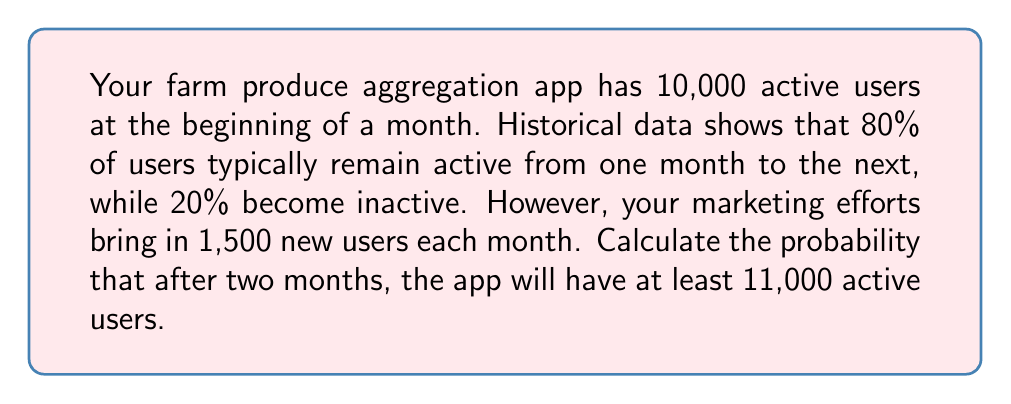Give your solution to this math problem. Let's approach this step-by-step:

1) First, let's calculate the number of active users after one month:
   - Retained users: $10,000 \times 0.8 = 8,000$
   - New users: $1,500$
   - Total after one month: $8,000 + 1,500 = 9,500$

2) Now, let's calculate the possible outcomes after two months:
   - Retained users from first month: $9,500 \times 0.8 = 7,600$
   - New users in second month: $1,500$
   - Total after two months: $7,600 + 1,500 = 9,100$

3) The question asks for the probability of having at least 11,000 users after two months. We can model this as a binomial distribution, where each user has a probability of 0.8 of remaining active.

4) Let $X$ be the number of active users after two months. We need $P(X \geq 11,000)$.

5) We can calculate this as $1 - P(X < 11,000)$

6) Using the normal approximation to the binomial distribution (since n is large):
   $\mu = np = 9,100 \times 0.8 = 7,280$
   $\sigma = \sqrt{np(1-p)} = \sqrt{9,100 \times 0.8 \times 0.2} = 38.17$

7) Standardizing:
   $z = \frac{11,000 - 7,280}{38.17} = 97.46$

8) Using a standard normal table or calculator, we find:
   $P(Z < 97.46) \approx 1$

9) Therefore, $P(X \geq 11,000) = 1 - P(X < 11,000) \approx 1 - 1 = 0$

The probability is essentially zero, meaning it's extremely unlikely to have 11,000 or more active users after two months given the current retention and acquisition rates.
Answer: $\approx 0$ 